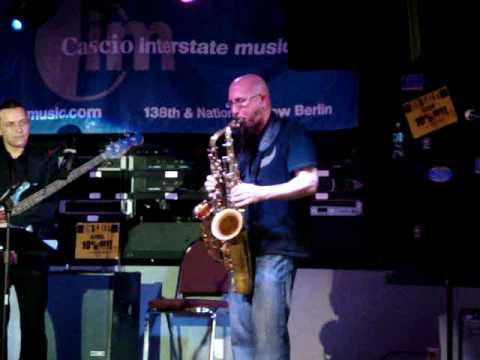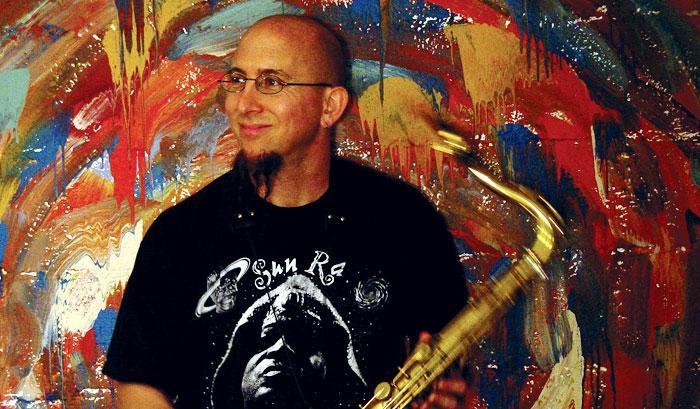The first image is the image on the left, the second image is the image on the right. Considering the images on both sides, is "Left image shows a man simultaneously playing two brass instruments, and the right image does not." valid? Answer yes or no. Yes. 